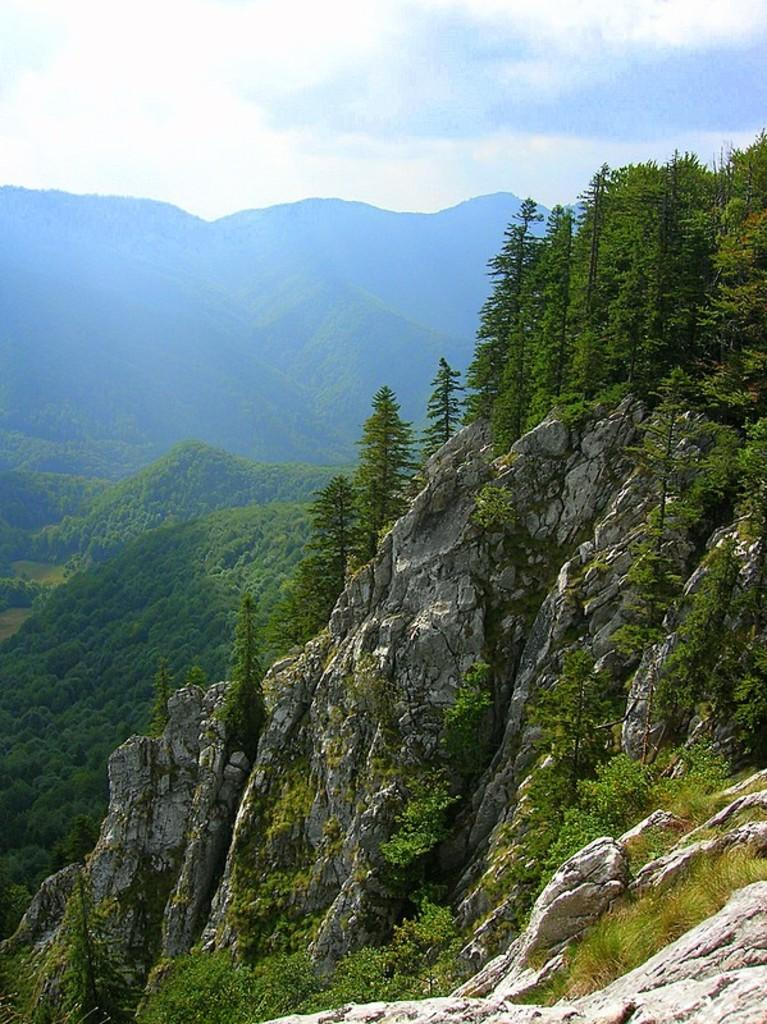What type of natural formation can be seen in the image? There are mountains in the image. What is present on the mountains? There are trees on the mountains. What can be seen in the background of the image? The sky is visible in the background of the image. What type of animal can be seen in the heart of the mountain in the image? There is no animal present in the heart of the mountain, as the image only shows mountains with trees and a visible sky in the background. 